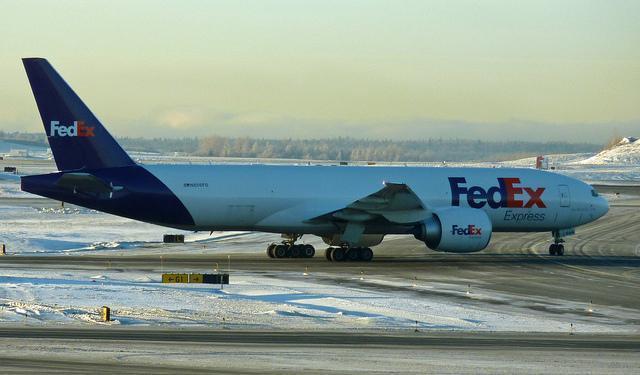How many cakes are there?
Give a very brief answer. 0. 